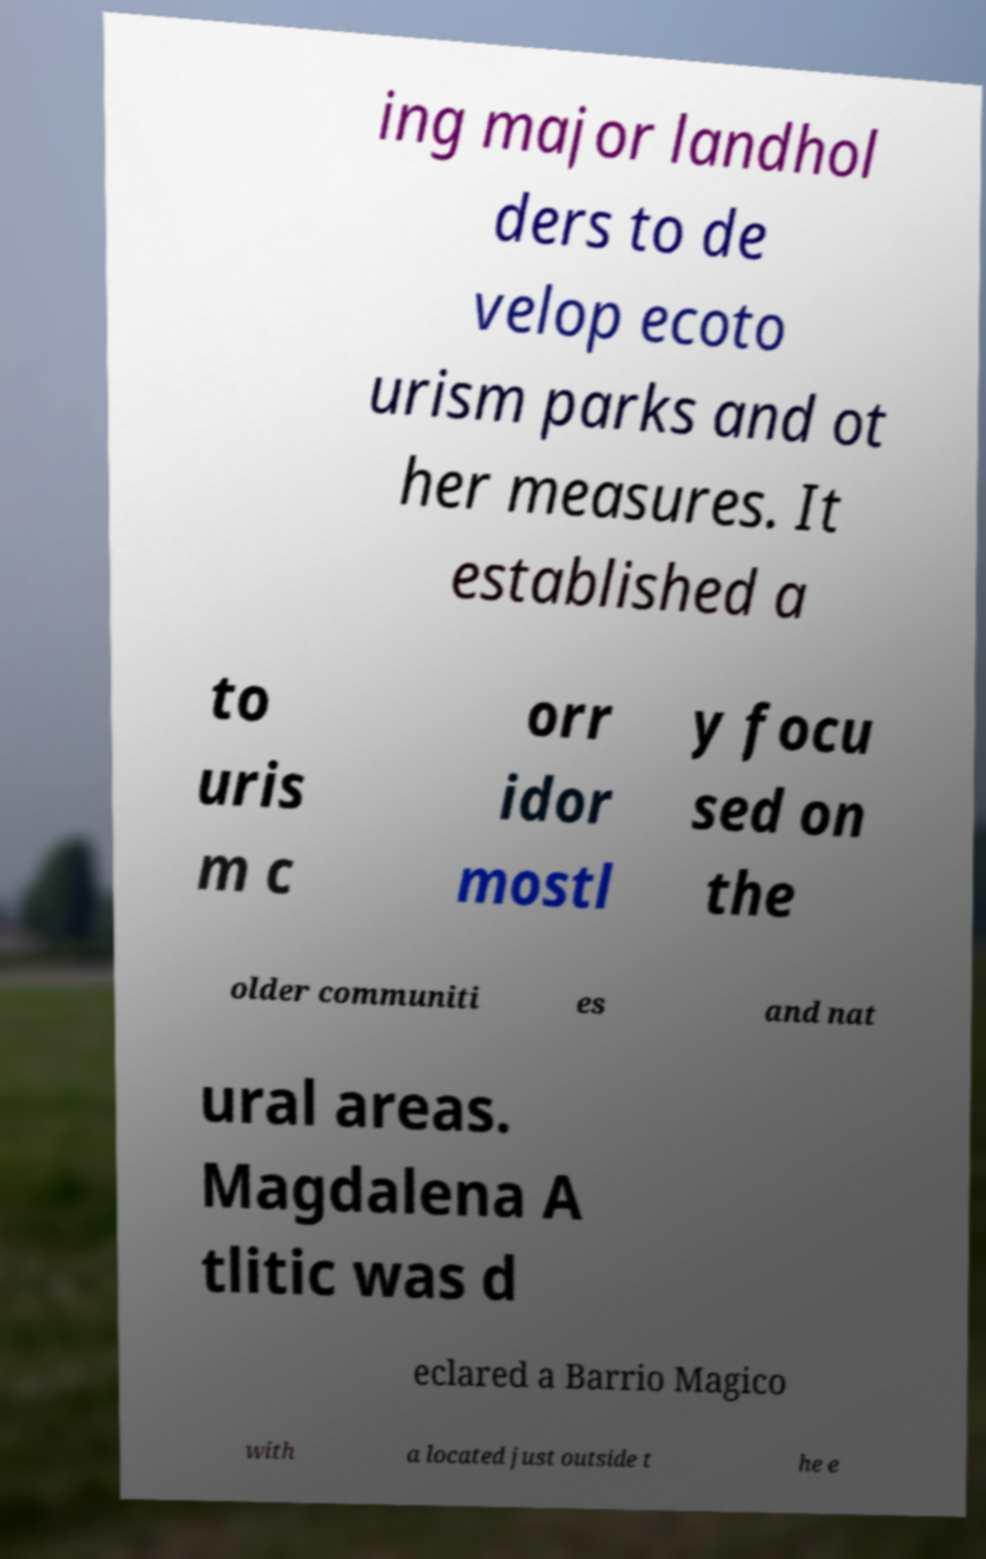For documentation purposes, I need the text within this image transcribed. Could you provide that? ing major landhol ders to de velop ecoto urism parks and ot her measures. It established a to uris m c orr idor mostl y focu sed on the older communiti es and nat ural areas. Magdalena A tlitic was d eclared a Barrio Magico with a located just outside t he e 